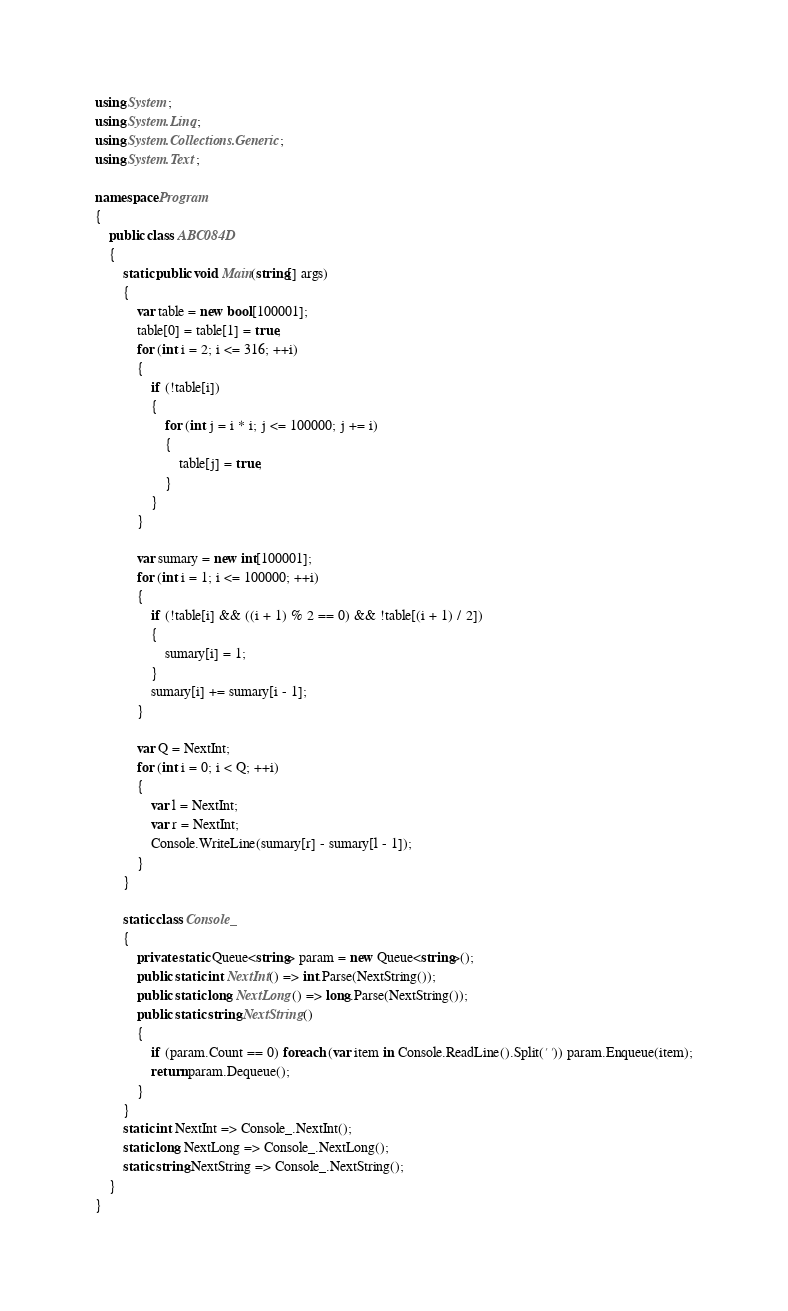<code> <loc_0><loc_0><loc_500><loc_500><_C#_>using System;
using System.Linq;
using System.Collections.Generic;
using System.Text;

namespace Program
{
    public class ABC084D
    {
        static public void Main(string[] args)
        {
            var table = new bool[100001];
            table[0] = table[1] = true;
            for (int i = 2; i <= 316; ++i)
            {
                if (!table[i])
                {
                    for (int j = i * i; j <= 100000; j += i)
                    {
                        table[j] = true;
                    }
                }
            }

            var sumary = new int[100001];
            for (int i = 1; i <= 100000; ++i)
            {
                if (!table[i] && ((i + 1) % 2 == 0) && !table[(i + 1) / 2])
                {
                    sumary[i] = 1;
                }
                sumary[i] += sumary[i - 1];
            }

            var Q = NextInt;
            for (int i = 0; i < Q; ++i)
            {
                var l = NextInt;
                var r = NextInt;
                Console.WriteLine(sumary[r] - sumary[l - 1]);
            }
        }

        static class Console_
        {
            private static Queue<string> param = new Queue<string>();
            public static int NextInt() => int.Parse(NextString());
            public static long NextLong() => long.Parse(NextString());
            public static string NextString()
            {
                if (param.Count == 0) foreach (var item in Console.ReadLine().Split(' ')) param.Enqueue(item);
                return param.Dequeue();
            }
        }
        static int NextInt => Console_.NextInt();
        static long NextLong => Console_.NextLong();
        static string NextString => Console_.NextString();
    }
}
</code> 